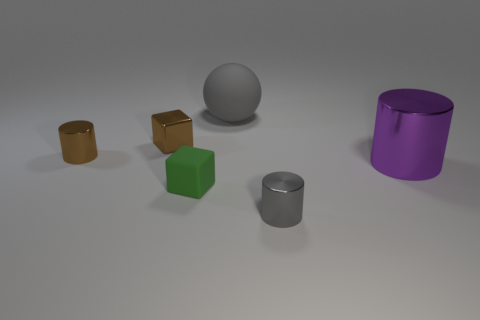Subtract all big purple metallic cylinders. How many cylinders are left? 2 Subtract all yellow cylinders. Subtract all red spheres. How many cylinders are left? 3 Add 3 gray objects. How many objects exist? 9 Subtract all balls. How many objects are left? 5 Subtract all small brown cylinders. Subtract all small matte objects. How many objects are left? 4 Add 4 big shiny objects. How many big shiny objects are left? 5 Add 2 small purple cylinders. How many small purple cylinders exist? 2 Subtract 0 red blocks. How many objects are left? 6 